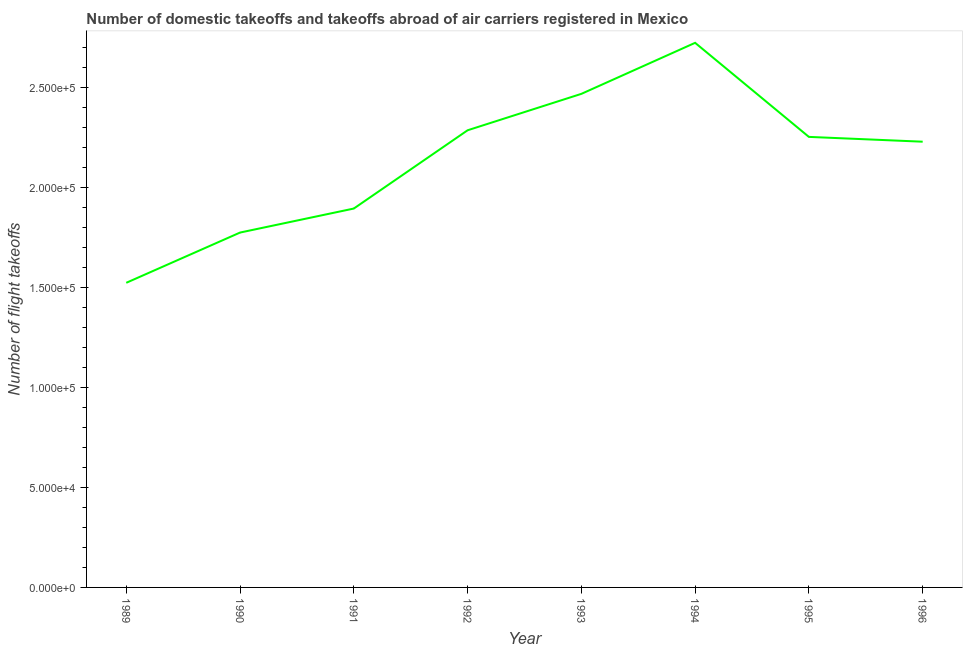What is the number of flight takeoffs in 1990?
Provide a short and direct response. 1.77e+05. Across all years, what is the maximum number of flight takeoffs?
Give a very brief answer. 2.72e+05. Across all years, what is the minimum number of flight takeoffs?
Give a very brief answer. 1.52e+05. What is the sum of the number of flight takeoffs?
Ensure brevity in your answer.  1.71e+06. What is the difference between the number of flight takeoffs in 1989 and 1990?
Your answer should be compact. -2.51e+04. What is the average number of flight takeoffs per year?
Offer a terse response. 2.14e+05. What is the median number of flight takeoffs?
Your answer should be very brief. 2.24e+05. In how many years, is the number of flight takeoffs greater than 140000 ?
Keep it short and to the point. 8. Do a majority of the years between 1996 and 1993 (inclusive) have number of flight takeoffs greater than 210000 ?
Provide a succinct answer. Yes. What is the ratio of the number of flight takeoffs in 1989 to that in 1994?
Provide a short and direct response. 0.56. Is the difference between the number of flight takeoffs in 1992 and 1994 greater than the difference between any two years?
Your answer should be compact. No. What is the difference between the highest and the second highest number of flight takeoffs?
Keep it short and to the point. 2.55e+04. Is the sum of the number of flight takeoffs in 1992 and 1993 greater than the maximum number of flight takeoffs across all years?
Your response must be concise. Yes. What is the difference between the highest and the lowest number of flight takeoffs?
Make the answer very short. 1.20e+05. Does the number of flight takeoffs monotonically increase over the years?
Provide a short and direct response. No. How many lines are there?
Ensure brevity in your answer.  1. How many years are there in the graph?
Give a very brief answer. 8. Are the values on the major ticks of Y-axis written in scientific E-notation?
Ensure brevity in your answer.  Yes. What is the title of the graph?
Your response must be concise. Number of domestic takeoffs and takeoffs abroad of air carriers registered in Mexico. What is the label or title of the X-axis?
Your response must be concise. Year. What is the label or title of the Y-axis?
Your answer should be compact. Number of flight takeoffs. What is the Number of flight takeoffs in 1989?
Give a very brief answer. 1.52e+05. What is the Number of flight takeoffs of 1990?
Keep it short and to the point. 1.77e+05. What is the Number of flight takeoffs of 1991?
Provide a succinct answer. 1.89e+05. What is the Number of flight takeoffs of 1992?
Ensure brevity in your answer.  2.28e+05. What is the Number of flight takeoffs of 1993?
Provide a short and direct response. 2.47e+05. What is the Number of flight takeoffs of 1994?
Give a very brief answer. 2.72e+05. What is the Number of flight takeoffs of 1995?
Your answer should be very brief. 2.25e+05. What is the Number of flight takeoffs of 1996?
Your response must be concise. 2.23e+05. What is the difference between the Number of flight takeoffs in 1989 and 1990?
Ensure brevity in your answer.  -2.51e+04. What is the difference between the Number of flight takeoffs in 1989 and 1991?
Make the answer very short. -3.71e+04. What is the difference between the Number of flight takeoffs in 1989 and 1992?
Your answer should be compact. -7.62e+04. What is the difference between the Number of flight takeoffs in 1989 and 1993?
Provide a short and direct response. -9.44e+04. What is the difference between the Number of flight takeoffs in 1989 and 1994?
Provide a succinct answer. -1.20e+05. What is the difference between the Number of flight takeoffs in 1989 and 1995?
Keep it short and to the point. -7.29e+04. What is the difference between the Number of flight takeoffs in 1989 and 1996?
Offer a terse response. -7.05e+04. What is the difference between the Number of flight takeoffs in 1990 and 1991?
Provide a short and direct response. -1.20e+04. What is the difference between the Number of flight takeoffs in 1990 and 1992?
Provide a short and direct response. -5.11e+04. What is the difference between the Number of flight takeoffs in 1990 and 1993?
Offer a very short reply. -6.93e+04. What is the difference between the Number of flight takeoffs in 1990 and 1994?
Ensure brevity in your answer.  -9.48e+04. What is the difference between the Number of flight takeoffs in 1990 and 1995?
Your answer should be very brief. -4.78e+04. What is the difference between the Number of flight takeoffs in 1990 and 1996?
Make the answer very short. -4.54e+04. What is the difference between the Number of flight takeoffs in 1991 and 1992?
Your answer should be very brief. -3.91e+04. What is the difference between the Number of flight takeoffs in 1991 and 1993?
Give a very brief answer. -5.73e+04. What is the difference between the Number of flight takeoffs in 1991 and 1994?
Provide a short and direct response. -8.28e+04. What is the difference between the Number of flight takeoffs in 1991 and 1995?
Your answer should be very brief. -3.58e+04. What is the difference between the Number of flight takeoffs in 1991 and 1996?
Offer a very short reply. -3.34e+04. What is the difference between the Number of flight takeoffs in 1992 and 1993?
Keep it short and to the point. -1.82e+04. What is the difference between the Number of flight takeoffs in 1992 and 1994?
Make the answer very short. -4.37e+04. What is the difference between the Number of flight takeoffs in 1992 and 1995?
Your answer should be compact. 3300. What is the difference between the Number of flight takeoffs in 1992 and 1996?
Ensure brevity in your answer.  5700. What is the difference between the Number of flight takeoffs in 1993 and 1994?
Offer a terse response. -2.55e+04. What is the difference between the Number of flight takeoffs in 1993 and 1995?
Keep it short and to the point. 2.15e+04. What is the difference between the Number of flight takeoffs in 1993 and 1996?
Your answer should be very brief. 2.39e+04. What is the difference between the Number of flight takeoffs in 1994 and 1995?
Your answer should be very brief. 4.70e+04. What is the difference between the Number of flight takeoffs in 1994 and 1996?
Keep it short and to the point. 4.94e+04. What is the difference between the Number of flight takeoffs in 1995 and 1996?
Offer a terse response. 2400. What is the ratio of the Number of flight takeoffs in 1989 to that in 1990?
Your response must be concise. 0.86. What is the ratio of the Number of flight takeoffs in 1989 to that in 1991?
Offer a very short reply. 0.8. What is the ratio of the Number of flight takeoffs in 1989 to that in 1992?
Your answer should be very brief. 0.67. What is the ratio of the Number of flight takeoffs in 1989 to that in 1993?
Provide a short and direct response. 0.62. What is the ratio of the Number of flight takeoffs in 1989 to that in 1994?
Your answer should be compact. 0.56. What is the ratio of the Number of flight takeoffs in 1989 to that in 1995?
Offer a very short reply. 0.68. What is the ratio of the Number of flight takeoffs in 1989 to that in 1996?
Give a very brief answer. 0.68. What is the ratio of the Number of flight takeoffs in 1990 to that in 1991?
Offer a very short reply. 0.94. What is the ratio of the Number of flight takeoffs in 1990 to that in 1992?
Make the answer very short. 0.78. What is the ratio of the Number of flight takeoffs in 1990 to that in 1993?
Provide a succinct answer. 0.72. What is the ratio of the Number of flight takeoffs in 1990 to that in 1994?
Keep it short and to the point. 0.65. What is the ratio of the Number of flight takeoffs in 1990 to that in 1995?
Offer a very short reply. 0.79. What is the ratio of the Number of flight takeoffs in 1990 to that in 1996?
Offer a very short reply. 0.8. What is the ratio of the Number of flight takeoffs in 1991 to that in 1992?
Keep it short and to the point. 0.83. What is the ratio of the Number of flight takeoffs in 1991 to that in 1993?
Provide a short and direct response. 0.77. What is the ratio of the Number of flight takeoffs in 1991 to that in 1994?
Give a very brief answer. 0.7. What is the ratio of the Number of flight takeoffs in 1991 to that in 1995?
Your response must be concise. 0.84. What is the ratio of the Number of flight takeoffs in 1992 to that in 1993?
Your answer should be very brief. 0.93. What is the ratio of the Number of flight takeoffs in 1992 to that in 1994?
Offer a very short reply. 0.84. What is the ratio of the Number of flight takeoffs in 1992 to that in 1996?
Provide a short and direct response. 1.03. What is the ratio of the Number of flight takeoffs in 1993 to that in 1994?
Your answer should be very brief. 0.91. What is the ratio of the Number of flight takeoffs in 1993 to that in 1995?
Ensure brevity in your answer.  1.1. What is the ratio of the Number of flight takeoffs in 1993 to that in 1996?
Provide a short and direct response. 1.11. What is the ratio of the Number of flight takeoffs in 1994 to that in 1995?
Offer a very short reply. 1.21. What is the ratio of the Number of flight takeoffs in 1994 to that in 1996?
Keep it short and to the point. 1.22. 